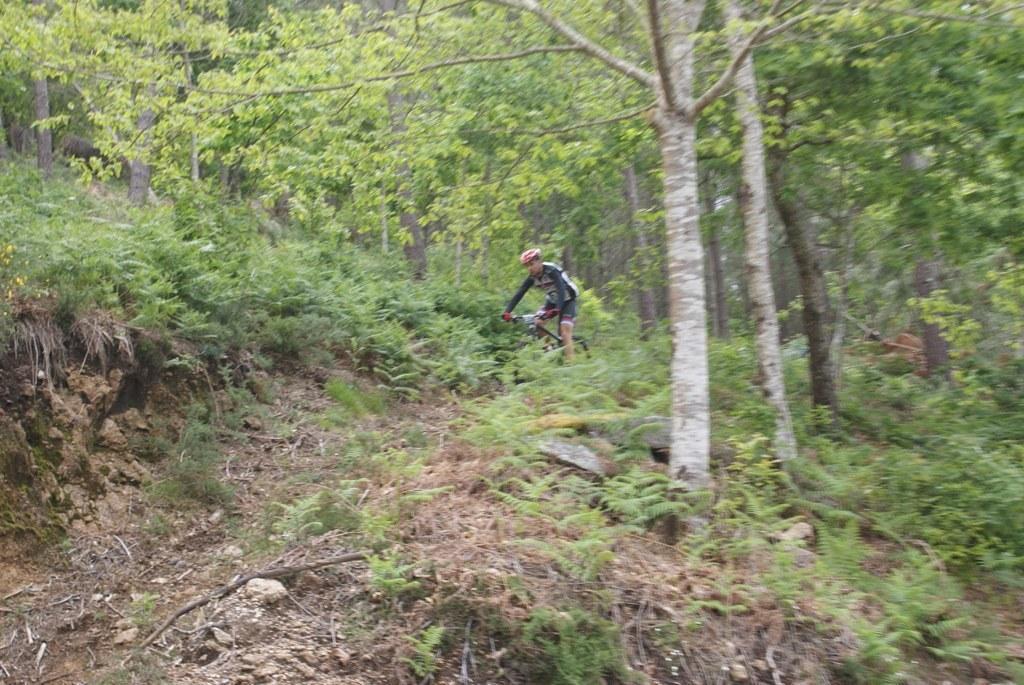How would you summarize this image in a sentence or two? In this image I can see few trees which are green in color, some grass which is green and brown in color and a person wearing black and white colored dress is riding a bicycle on the ground. 